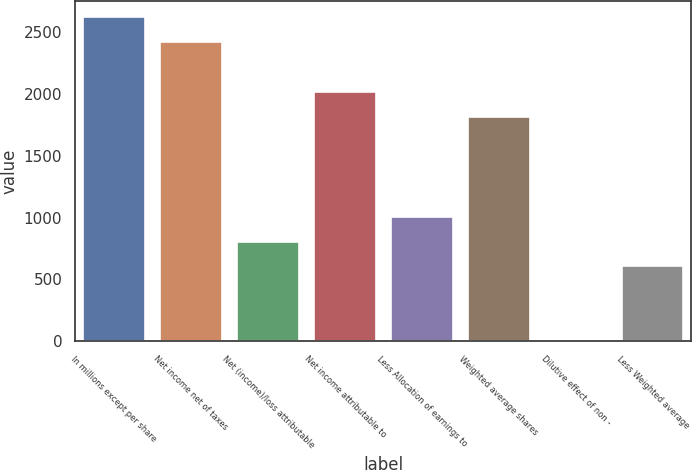Convert chart to OTSL. <chart><loc_0><loc_0><loc_500><loc_500><bar_chart><fcel>In millions except per share<fcel>Net income net of taxes<fcel>Net (income)/loss attributable<fcel>Net income attributable to<fcel>Less Allocation of earnings to<fcel>Weighted average shares<fcel>Dilutive effect of non -<fcel>Less Weighted average<nl><fcel>2620.71<fcel>2419.14<fcel>806.58<fcel>2016<fcel>1008.15<fcel>1814.43<fcel>0.3<fcel>605.01<nl></chart> 